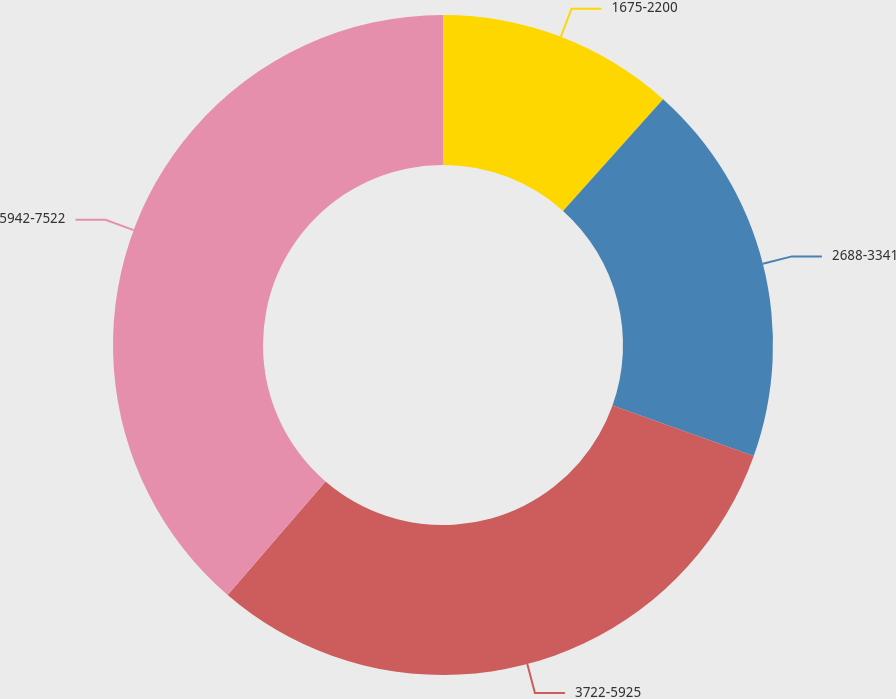Convert chart to OTSL. <chart><loc_0><loc_0><loc_500><loc_500><pie_chart><fcel>1675-2200<fcel>2688-3341<fcel>3722-5925<fcel>5942-7522<nl><fcel>11.62%<fcel>18.84%<fcel>30.85%<fcel>38.68%<nl></chart> 